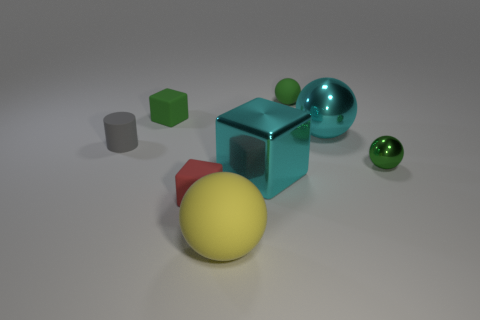Add 1 gray metallic balls. How many objects exist? 9 Subtract all cubes. How many objects are left? 5 Subtract 1 cyan cubes. How many objects are left? 7 Subtract all yellow rubber cubes. Subtract all big shiny balls. How many objects are left? 7 Add 6 cyan metallic blocks. How many cyan metallic blocks are left? 7 Add 1 red matte spheres. How many red matte spheres exist? 1 